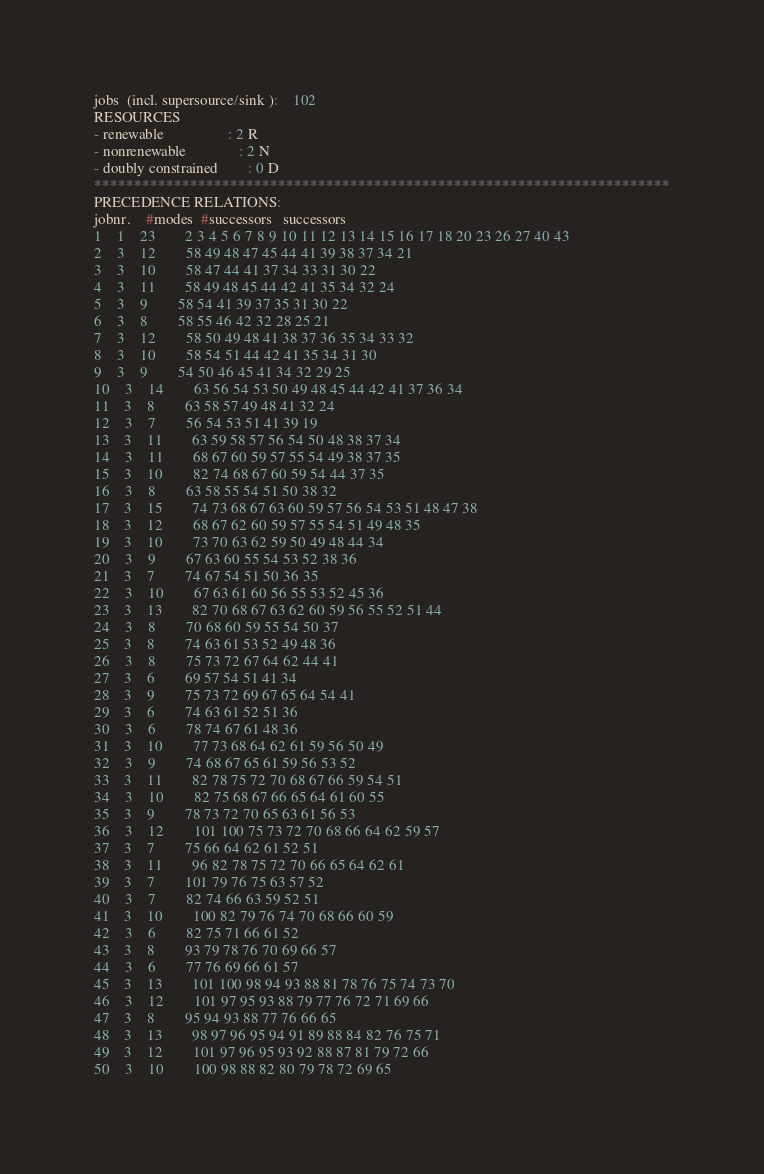<code> <loc_0><loc_0><loc_500><loc_500><_ObjectiveC_>jobs  (incl. supersource/sink ):	102
RESOURCES
- renewable                 : 2 R
- nonrenewable              : 2 N
- doubly constrained        : 0 D
************************************************************************
PRECEDENCE RELATIONS:
jobnr.    #modes  #successors   successors
1	1	23		2 3 4 5 6 7 8 9 10 11 12 13 14 15 16 17 18 20 23 26 27 40 43 
2	3	12		58 49 48 47 45 44 41 39 38 37 34 21 
3	3	10		58 47 44 41 37 34 33 31 30 22 
4	3	11		58 49 48 45 44 42 41 35 34 32 24 
5	3	9		58 54 41 39 37 35 31 30 22 
6	3	8		58 55 46 42 32 28 25 21 
7	3	12		58 50 49 48 41 38 37 36 35 34 33 32 
8	3	10		58 54 51 44 42 41 35 34 31 30 
9	3	9		54 50 46 45 41 34 32 29 25 
10	3	14		63 56 54 53 50 49 48 45 44 42 41 37 36 34 
11	3	8		63 58 57 49 48 41 32 24 
12	3	7		56 54 53 51 41 39 19 
13	3	11		63 59 58 57 56 54 50 48 38 37 34 
14	3	11		68 67 60 59 57 55 54 49 38 37 35 
15	3	10		82 74 68 67 60 59 54 44 37 35 
16	3	8		63 58 55 54 51 50 38 32 
17	3	15		74 73 68 67 63 60 59 57 56 54 53 51 48 47 38 
18	3	12		68 67 62 60 59 57 55 54 51 49 48 35 
19	3	10		73 70 63 62 59 50 49 48 44 34 
20	3	9		67 63 60 55 54 53 52 38 36 
21	3	7		74 67 54 51 50 36 35 
22	3	10		67 63 61 60 56 55 53 52 45 36 
23	3	13		82 70 68 67 63 62 60 59 56 55 52 51 44 
24	3	8		70 68 60 59 55 54 50 37 
25	3	8		74 63 61 53 52 49 48 36 
26	3	8		75 73 72 67 64 62 44 41 
27	3	6		69 57 54 51 41 34 
28	3	9		75 73 72 69 67 65 64 54 41 
29	3	6		74 63 61 52 51 36 
30	3	6		78 74 67 61 48 36 
31	3	10		77 73 68 64 62 61 59 56 50 49 
32	3	9		74 68 67 65 61 59 56 53 52 
33	3	11		82 78 75 72 70 68 67 66 59 54 51 
34	3	10		82 75 68 67 66 65 64 61 60 55 
35	3	9		78 73 72 70 65 63 61 56 53 
36	3	12		101 100 75 73 72 70 68 66 64 62 59 57 
37	3	7		75 66 64 62 61 52 51 
38	3	11		96 82 78 75 72 70 66 65 64 62 61 
39	3	7		101 79 76 75 63 57 52 
40	3	7		82 74 66 63 59 52 51 
41	3	10		100 82 79 76 74 70 68 66 60 59 
42	3	6		82 75 71 66 61 52 
43	3	8		93 79 78 76 70 69 66 57 
44	3	6		77 76 69 66 61 57 
45	3	13		101 100 98 94 93 88 81 78 76 75 74 73 70 
46	3	12		101 97 95 93 88 79 77 76 72 71 69 66 
47	3	8		95 94 93 88 77 76 66 65 
48	3	13		98 97 96 95 94 91 89 88 84 82 76 75 71 
49	3	12		101 97 96 95 93 92 88 87 81 79 72 66 
50	3	10		100 98 88 82 80 79 78 72 69 65 </code> 